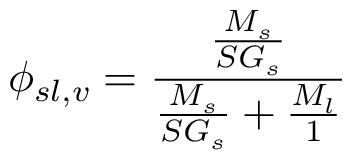<formula> <loc_0><loc_0><loc_500><loc_500>\phi _ { s l , v } = { \frac { \frac { M _ { s } } { S G _ { s } } } { { \frac { M _ { s } } { S G _ { s } } } + { \frac { M _ { l } } { 1 } } } }</formula> 